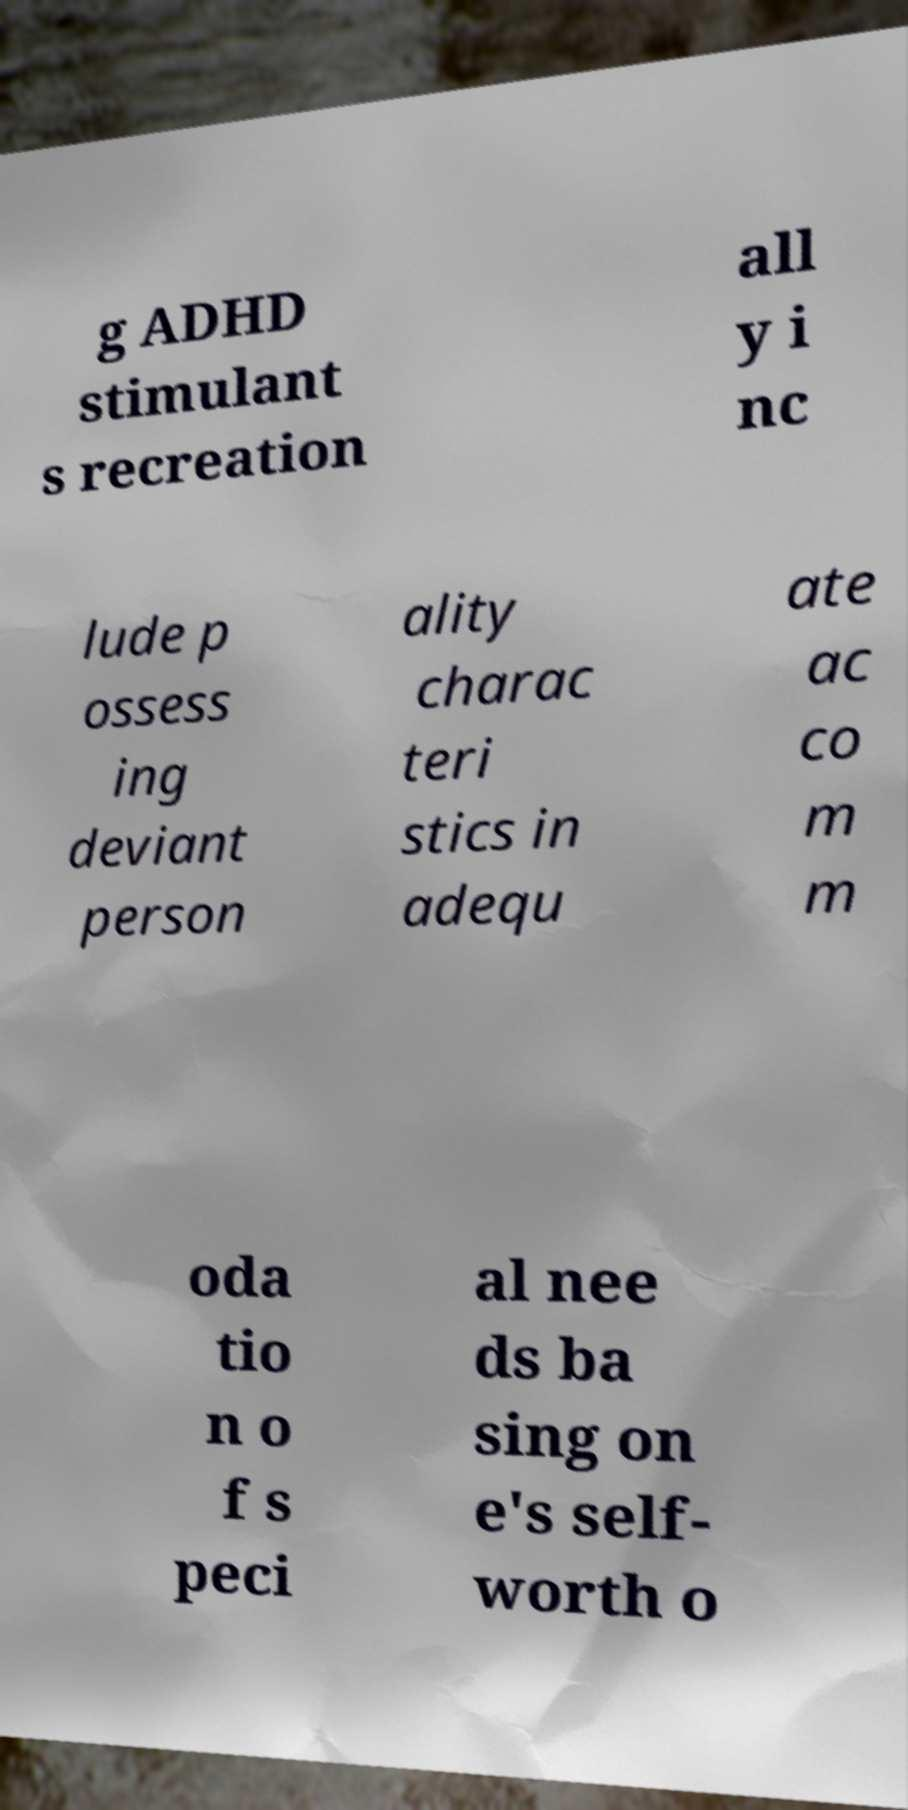I need the written content from this picture converted into text. Can you do that? g ADHD stimulant s recreation all y i nc lude p ossess ing deviant person ality charac teri stics in adequ ate ac co m m oda tio n o f s peci al nee ds ba sing on e's self- worth o 